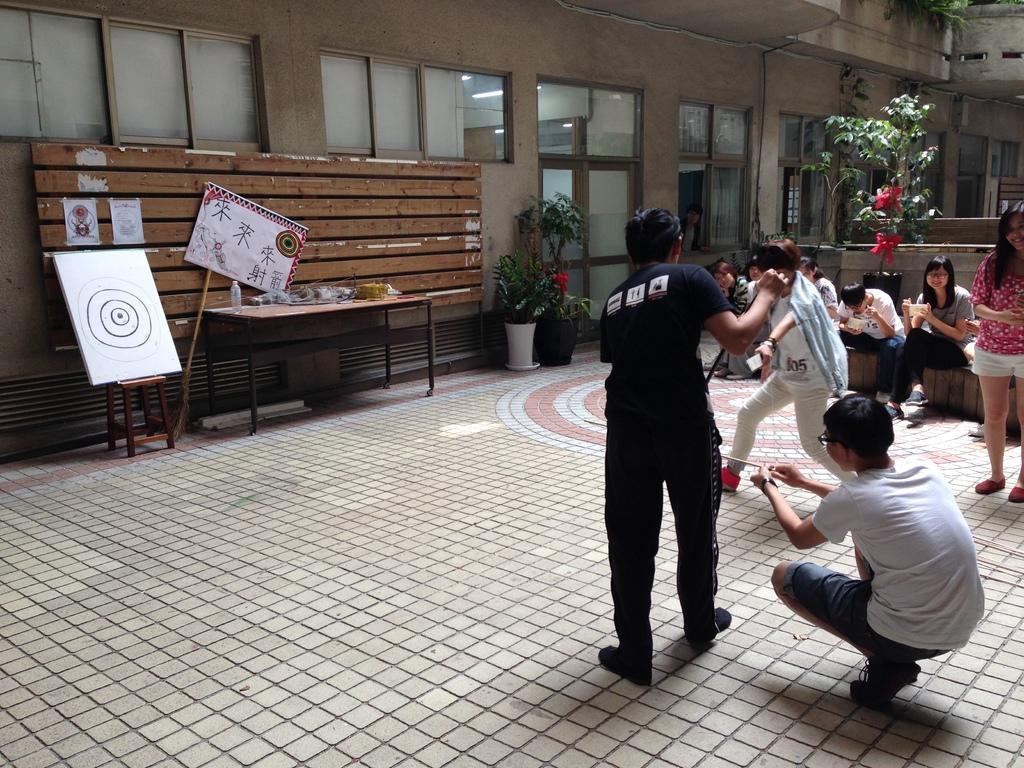Could you give a brief overview of what you see in this image? Here we can see a group of people both Standing and sitting, they are trying to perform an act and behind them we can see a plant and opposite to them there is a building and there is a table present opposite to them and beside the table we can see a chart board 